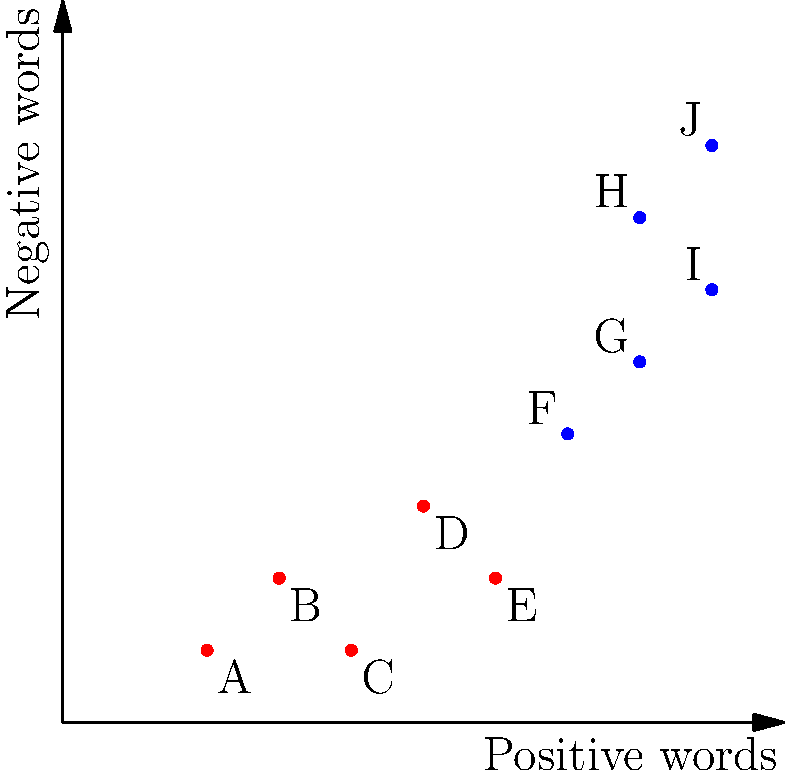As the head of a local Buddhist center, you're analyzing feedback forms from a recent meditation retreat. The scatter plot shows the number of positive and negative words used in each response. Which group of responses (A-E or F-J) likely represents more satisfied participants, and what Buddhist principle might explain the presence of both positive and negative feedback? To answer this question, we need to analyze the scatter plot and apply Buddhist principles:

1. Interpret the scatter plot:
   - The x-axis represents the number of positive words.
   - The y-axis represents the number of negative words.
   - Each point represents a participant's feedback.

2. Compare the two groups:
   - Group A-E (red dots) has fewer positive words (2-6) and fewer negative words (1-3).
   - Group F-J (blue dots) has more positive words (7-9) but also more negative words (4-8).

3. Determine which group represents more satisfied participants:
   - Despite having more negative words, group F-J has significantly more positive words.
   - This suggests that group F-J likely represents more satisfied participants overall.

4. Apply Buddhist principles:
   - The presence of both positive and negative feedback can be explained by the Buddhist concept of "Middle Way" (madhyamā-pratipad).
   - This principle teaches balance and avoiding extremes, recognizing that both positive and negative experiences coexist.

5. Relate to meditation practice:
   - During meditation retreats, participants often experience a range of emotions and insights.
   - The ability to acknowledge both positive and challenging aspects of the experience indicates a balanced and mindful approach.
Answer: Group F-J; Middle Way (madhyamā-pratipad) 